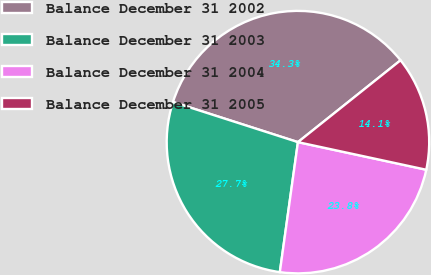<chart> <loc_0><loc_0><loc_500><loc_500><pie_chart><fcel>Balance December 31 2002<fcel>Balance December 31 2003<fcel>Balance December 31 2004<fcel>Balance December 31 2005<nl><fcel>34.34%<fcel>27.74%<fcel>23.83%<fcel>14.09%<nl></chart> 